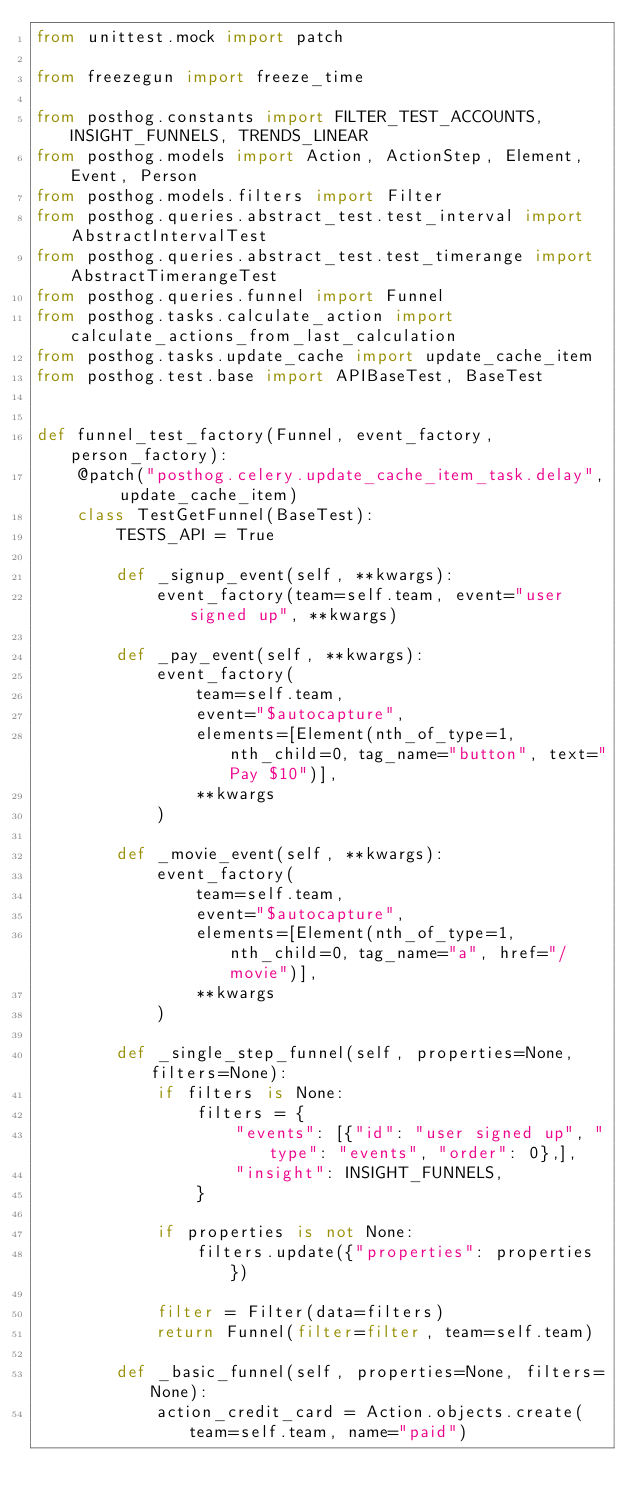Convert code to text. <code><loc_0><loc_0><loc_500><loc_500><_Python_>from unittest.mock import patch

from freezegun import freeze_time

from posthog.constants import FILTER_TEST_ACCOUNTS, INSIGHT_FUNNELS, TRENDS_LINEAR
from posthog.models import Action, ActionStep, Element, Event, Person
from posthog.models.filters import Filter
from posthog.queries.abstract_test.test_interval import AbstractIntervalTest
from posthog.queries.abstract_test.test_timerange import AbstractTimerangeTest
from posthog.queries.funnel import Funnel
from posthog.tasks.calculate_action import calculate_actions_from_last_calculation
from posthog.tasks.update_cache import update_cache_item
from posthog.test.base import APIBaseTest, BaseTest


def funnel_test_factory(Funnel, event_factory, person_factory):
    @patch("posthog.celery.update_cache_item_task.delay", update_cache_item)
    class TestGetFunnel(BaseTest):
        TESTS_API = True

        def _signup_event(self, **kwargs):
            event_factory(team=self.team, event="user signed up", **kwargs)

        def _pay_event(self, **kwargs):
            event_factory(
                team=self.team,
                event="$autocapture",
                elements=[Element(nth_of_type=1, nth_child=0, tag_name="button", text="Pay $10")],
                **kwargs
            )

        def _movie_event(self, **kwargs):
            event_factory(
                team=self.team,
                event="$autocapture",
                elements=[Element(nth_of_type=1, nth_child=0, tag_name="a", href="/movie")],
                **kwargs
            )

        def _single_step_funnel(self, properties=None, filters=None):
            if filters is None:
                filters = {
                    "events": [{"id": "user signed up", "type": "events", "order": 0},],
                    "insight": INSIGHT_FUNNELS,
                }

            if properties is not None:
                filters.update({"properties": properties})

            filter = Filter(data=filters)
            return Funnel(filter=filter, team=self.team)

        def _basic_funnel(self, properties=None, filters=None):
            action_credit_card = Action.objects.create(team=self.team, name="paid")</code> 